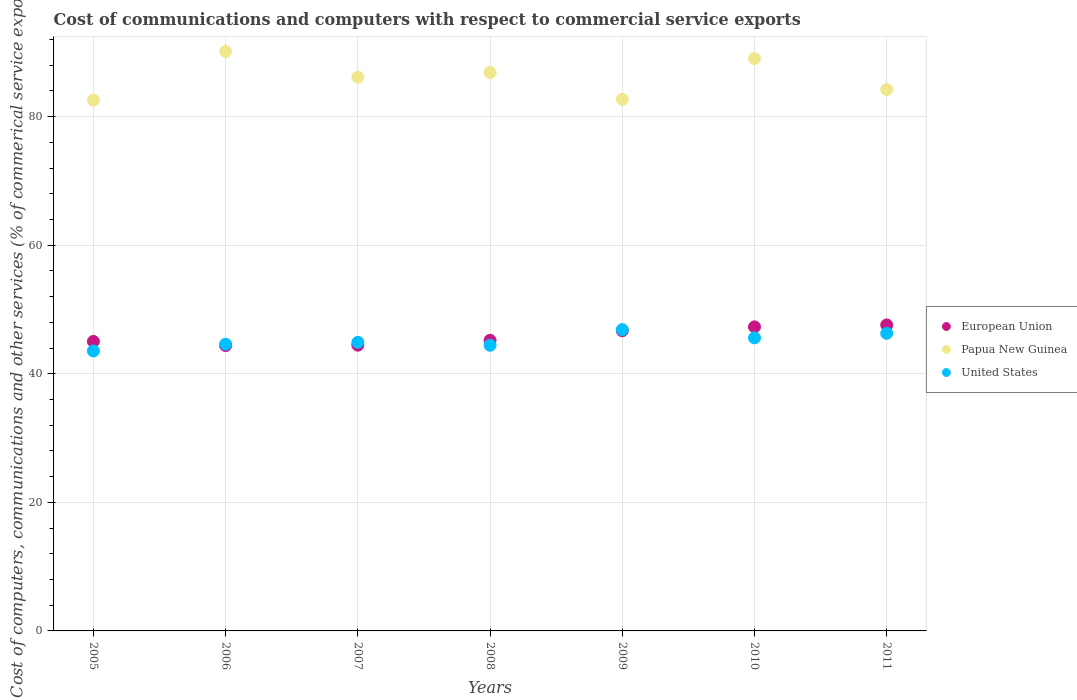Is the number of dotlines equal to the number of legend labels?
Make the answer very short. Yes. What is the cost of communications and computers in European Union in 2011?
Make the answer very short. 47.59. Across all years, what is the maximum cost of communications and computers in Papua New Guinea?
Provide a succinct answer. 90.12. Across all years, what is the minimum cost of communications and computers in United States?
Provide a short and direct response. 43.55. In which year was the cost of communications and computers in United States maximum?
Your answer should be compact. 2009. In which year was the cost of communications and computers in United States minimum?
Your response must be concise. 2005. What is the total cost of communications and computers in European Union in the graph?
Give a very brief answer. 320.63. What is the difference between the cost of communications and computers in Papua New Guinea in 2005 and that in 2007?
Ensure brevity in your answer.  -3.58. What is the difference between the cost of communications and computers in European Union in 2009 and the cost of communications and computers in United States in 2007?
Your response must be concise. 1.8. What is the average cost of communications and computers in United States per year?
Offer a very short reply. 45.17. In the year 2009, what is the difference between the cost of communications and computers in European Union and cost of communications and computers in United States?
Your answer should be compact. -0.17. In how many years, is the cost of communications and computers in United States greater than 28 %?
Keep it short and to the point. 7. What is the ratio of the cost of communications and computers in European Union in 2008 to that in 2010?
Make the answer very short. 0.96. What is the difference between the highest and the second highest cost of communications and computers in United States?
Your answer should be compact. 0.57. What is the difference between the highest and the lowest cost of communications and computers in United States?
Offer a terse response. 3.31. Is it the case that in every year, the sum of the cost of communications and computers in United States and cost of communications and computers in Papua New Guinea  is greater than the cost of communications and computers in European Union?
Provide a short and direct response. Yes. Is the cost of communications and computers in Papua New Guinea strictly greater than the cost of communications and computers in European Union over the years?
Ensure brevity in your answer.  Yes. What is the difference between two consecutive major ticks on the Y-axis?
Ensure brevity in your answer.  20. Are the values on the major ticks of Y-axis written in scientific E-notation?
Make the answer very short. No. Does the graph contain grids?
Provide a short and direct response. Yes. Where does the legend appear in the graph?
Your answer should be compact. Center right. How many legend labels are there?
Provide a short and direct response. 3. How are the legend labels stacked?
Your response must be concise. Vertical. What is the title of the graph?
Ensure brevity in your answer.  Cost of communications and computers with respect to commercial service exports. What is the label or title of the Y-axis?
Provide a succinct answer. Cost of computers, communications and other services (% of commerical service exports). What is the Cost of computers, communications and other services (% of commerical service exports) of European Union in 2005?
Offer a very short reply. 45.03. What is the Cost of computers, communications and other services (% of commerical service exports) in Papua New Guinea in 2005?
Offer a terse response. 82.56. What is the Cost of computers, communications and other services (% of commerical service exports) of United States in 2005?
Ensure brevity in your answer.  43.55. What is the Cost of computers, communications and other services (% of commerical service exports) in European Union in 2006?
Keep it short and to the point. 44.38. What is the Cost of computers, communications and other services (% of commerical service exports) of Papua New Guinea in 2006?
Give a very brief answer. 90.12. What is the Cost of computers, communications and other services (% of commerical service exports) of United States in 2006?
Your response must be concise. 44.6. What is the Cost of computers, communications and other services (% of commerical service exports) of European Union in 2007?
Your answer should be very brief. 44.44. What is the Cost of computers, communications and other services (% of commerical service exports) of Papua New Guinea in 2007?
Make the answer very short. 86.14. What is the Cost of computers, communications and other services (% of commerical service exports) of United States in 2007?
Keep it short and to the point. 44.89. What is the Cost of computers, communications and other services (% of commerical service exports) of European Union in 2008?
Give a very brief answer. 45.2. What is the Cost of computers, communications and other services (% of commerical service exports) in Papua New Guinea in 2008?
Make the answer very short. 86.87. What is the Cost of computers, communications and other services (% of commerical service exports) of United States in 2008?
Offer a terse response. 44.43. What is the Cost of computers, communications and other services (% of commerical service exports) of European Union in 2009?
Offer a very short reply. 46.69. What is the Cost of computers, communications and other services (% of commerical service exports) of Papua New Guinea in 2009?
Make the answer very short. 82.68. What is the Cost of computers, communications and other services (% of commerical service exports) of United States in 2009?
Provide a succinct answer. 46.86. What is the Cost of computers, communications and other services (% of commerical service exports) of European Union in 2010?
Your answer should be compact. 47.29. What is the Cost of computers, communications and other services (% of commerical service exports) of Papua New Guinea in 2010?
Your answer should be compact. 89.03. What is the Cost of computers, communications and other services (% of commerical service exports) in United States in 2010?
Give a very brief answer. 45.58. What is the Cost of computers, communications and other services (% of commerical service exports) of European Union in 2011?
Provide a short and direct response. 47.59. What is the Cost of computers, communications and other services (% of commerical service exports) of Papua New Guinea in 2011?
Make the answer very short. 84.21. What is the Cost of computers, communications and other services (% of commerical service exports) in United States in 2011?
Provide a succinct answer. 46.29. Across all years, what is the maximum Cost of computers, communications and other services (% of commerical service exports) in European Union?
Ensure brevity in your answer.  47.59. Across all years, what is the maximum Cost of computers, communications and other services (% of commerical service exports) in Papua New Guinea?
Offer a terse response. 90.12. Across all years, what is the maximum Cost of computers, communications and other services (% of commerical service exports) of United States?
Provide a succinct answer. 46.86. Across all years, what is the minimum Cost of computers, communications and other services (% of commerical service exports) in European Union?
Give a very brief answer. 44.38. Across all years, what is the minimum Cost of computers, communications and other services (% of commerical service exports) in Papua New Guinea?
Ensure brevity in your answer.  82.56. Across all years, what is the minimum Cost of computers, communications and other services (% of commerical service exports) in United States?
Ensure brevity in your answer.  43.55. What is the total Cost of computers, communications and other services (% of commerical service exports) in European Union in the graph?
Keep it short and to the point. 320.63. What is the total Cost of computers, communications and other services (% of commerical service exports) in Papua New Guinea in the graph?
Make the answer very short. 601.6. What is the total Cost of computers, communications and other services (% of commerical service exports) of United States in the graph?
Your answer should be compact. 316.21. What is the difference between the Cost of computers, communications and other services (% of commerical service exports) in European Union in 2005 and that in 2006?
Your answer should be compact. 0.65. What is the difference between the Cost of computers, communications and other services (% of commerical service exports) in Papua New Guinea in 2005 and that in 2006?
Your answer should be very brief. -7.56. What is the difference between the Cost of computers, communications and other services (% of commerical service exports) in United States in 2005 and that in 2006?
Make the answer very short. -1.05. What is the difference between the Cost of computers, communications and other services (% of commerical service exports) of European Union in 2005 and that in 2007?
Offer a very short reply. 0.59. What is the difference between the Cost of computers, communications and other services (% of commerical service exports) of Papua New Guinea in 2005 and that in 2007?
Your answer should be very brief. -3.58. What is the difference between the Cost of computers, communications and other services (% of commerical service exports) in United States in 2005 and that in 2007?
Offer a very short reply. -1.34. What is the difference between the Cost of computers, communications and other services (% of commerical service exports) in European Union in 2005 and that in 2008?
Make the answer very short. -0.17. What is the difference between the Cost of computers, communications and other services (% of commerical service exports) in Papua New Guinea in 2005 and that in 2008?
Ensure brevity in your answer.  -4.32. What is the difference between the Cost of computers, communications and other services (% of commerical service exports) of United States in 2005 and that in 2008?
Provide a short and direct response. -0.88. What is the difference between the Cost of computers, communications and other services (% of commerical service exports) of European Union in 2005 and that in 2009?
Your response must be concise. -1.66. What is the difference between the Cost of computers, communications and other services (% of commerical service exports) of Papua New Guinea in 2005 and that in 2009?
Offer a terse response. -0.12. What is the difference between the Cost of computers, communications and other services (% of commerical service exports) in United States in 2005 and that in 2009?
Ensure brevity in your answer.  -3.31. What is the difference between the Cost of computers, communications and other services (% of commerical service exports) of European Union in 2005 and that in 2010?
Keep it short and to the point. -2.26. What is the difference between the Cost of computers, communications and other services (% of commerical service exports) of Papua New Guinea in 2005 and that in 2010?
Offer a very short reply. -6.47. What is the difference between the Cost of computers, communications and other services (% of commerical service exports) of United States in 2005 and that in 2010?
Give a very brief answer. -2.03. What is the difference between the Cost of computers, communications and other services (% of commerical service exports) of European Union in 2005 and that in 2011?
Your response must be concise. -2.56. What is the difference between the Cost of computers, communications and other services (% of commerical service exports) of Papua New Guinea in 2005 and that in 2011?
Keep it short and to the point. -1.66. What is the difference between the Cost of computers, communications and other services (% of commerical service exports) of United States in 2005 and that in 2011?
Your answer should be very brief. -2.74. What is the difference between the Cost of computers, communications and other services (% of commerical service exports) of European Union in 2006 and that in 2007?
Keep it short and to the point. -0.06. What is the difference between the Cost of computers, communications and other services (% of commerical service exports) of Papua New Guinea in 2006 and that in 2007?
Provide a short and direct response. 3.98. What is the difference between the Cost of computers, communications and other services (% of commerical service exports) of United States in 2006 and that in 2007?
Provide a succinct answer. -0.3. What is the difference between the Cost of computers, communications and other services (% of commerical service exports) of European Union in 2006 and that in 2008?
Ensure brevity in your answer.  -0.82. What is the difference between the Cost of computers, communications and other services (% of commerical service exports) in Papua New Guinea in 2006 and that in 2008?
Make the answer very short. 3.25. What is the difference between the Cost of computers, communications and other services (% of commerical service exports) of United States in 2006 and that in 2008?
Offer a very short reply. 0.17. What is the difference between the Cost of computers, communications and other services (% of commerical service exports) of European Union in 2006 and that in 2009?
Offer a terse response. -2.31. What is the difference between the Cost of computers, communications and other services (% of commerical service exports) of Papua New Guinea in 2006 and that in 2009?
Your answer should be compact. 7.44. What is the difference between the Cost of computers, communications and other services (% of commerical service exports) of United States in 2006 and that in 2009?
Ensure brevity in your answer.  -2.27. What is the difference between the Cost of computers, communications and other services (% of commerical service exports) in European Union in 2006 and that in 2010?
Your answer should be very brief. -2.91. What is the difference between the Cost of computers, communications and other services (% of commerical service exports) of Papua New Guinea in 2006 and that in 2010?
Offer a very short reply. 1.09. What is the difference between the Cost of computers, communications and other services (% of commerical service exports) in United States in 2006 and that in 2010?
Your answer should be compact. -0.99. What is the difference between the Cost of computers, communications and other services (% of commerical service exports) of European Union in 2006 and that in 2011?
Provide a short and direct response. -3.21. What is the difference between the Cost of computers, communications and other services (% of commerical service exports) in Papua New Guinea in 2006 and that in 2011?
Your answer should be very brief. 5.9. What is the difference between the Cost of computers, communications and other services (% of commerical service exports) in United States in 2006 and that in 2011?
Provide a succinct answer. -1.7. What is the difference between the Cost of computers, communications and other services (% of commerical service exports) in European Union in 2007 and that in 2008?
Offer a very short reply. -0.76. What is the difference between the Cost of computers, communications and other services (% of commerical service exports) of Papua New Guinea in 2007 and that in 2008?
Offer a terse response. -0.73. What is the difference between the Cost of computers, communications and other services (% of commerical service exports) of United States in 2007 and that in 2008?
Your answer should be compact. 0.46. What is the difference between the Cost of computers, communications and other services (% of commerical service exports) in European Union in 2007 and that in 2009?
Keep it short and to the point. -2.25. What is the difference between the Cost of computers, communications and other services (% of commerical service exports) of Papua New Guinea in 2007 and that in 2009?
Provide a short and direct response. 3.46. What is the difference between the Cost of computers, communications and other services (% of commerical service exports) in United States in 2007 and that in 2009?
Ensure brevity in your answer.  -1.97. What is the difference between the Cost of computers, communications and other services (% of commerical service exports) in European Union in 2007 and that in 2010?
Provide a short and direct response. -2.85. What is the difference between the Cost of computers, communications and other services (% of commerical service exports) in Papua New Guinea in 2007 and that in 2010?
Give a very brief answer. -2.88. What is the difference between the Cost of computers, communications and other services (% of commerical service exports) of United States in 2007 and that in 2010?
Your answer should be very brief. -0.69. What is the difference between the Cost of computers, communications and other services (% of commerical service exports) in European Union in 2007 and that in 2011?
Provide a succinct answer. -3.15. What is the difference between the Cost of computers, communications and other services (% of commerical service exports) of Papua New Guinea in 2007 and that in 2011?
Provide a succinct answer. 1.93. What is the difference between the Cost of computers, communications and other services (% of commerical service exports) in United States in 2007 and that in 2011?
Make the answer very short. -1.4. What is the difference between the Cost of computers, communications and other services (% of commerical service exports) of European Union in 2008 and that in 2009?
Give a very brief answer. -1.49. What is the difference between the Cost of computers, communications and other services (% of commerical service exports) in Papua New Guinea in 2008 and that in 2009?
Your answer should be compact. 4.19. What is the difference between the Cost of computers, communications and other services (% of commerical service exports) in United States in 2008 and that in 2009?
Your answer should be compact. -2.43. What is the difference between the Cost of computers, communications and other services (% of commerical service exports) in European Union in 2008 and that in 2010?
Offer a very short reply. -2.09. What is the difference between the Cost of computers, communications and other services (% of commerical service exports) in Papua New Guinea in 2008 and that in 2010?
Ensure brevity in your answer.  -2.15. What is the difference between the Cost of computers, communications and other services (% of commerical service exports) in United States in 2008 and that in 2010?
Keep it short and to the point. -1.15. What is the difference between the Cost of computers, communications and other services (% of commerical service exports) in European Union in 2008 and that in 2011?
Give a very brief answer. -2.39. What is the difference between the Cost of computers, communications and other services (% of commerical service exports) in Papua New Guinea in 2008 and that in 2011?
Give a very brief answer. 2.66. What is the difference between the Cost of computers, communications and other services (% of commerical service exports) of United States in 2008 and that in 2011?
Provide a succinct answer. -1.86. What is the difference between the Cost of computers, communications and other services (% of commerical service exports) in European Union in 2009 and that in 2010?
Your response must be concise. -0.6. What is the difference between the Cost of computers, communications and other services (% of commerical service exports) in Papua New Guinea in 2009 and that in 2010?
Give a very brief answer. -6.35. What is the difference between the Cost of computers, communications and other services (% of commerical service exports) in United States in 2009 and that in 2010?
Your answer should be very brief. 1.28. What is the difference between the Cost of computers, communications and other services (% of commerical service exports) in European Union in 2009 and that in 2011?
Ensure brevity in your answer.  -0.9. What is the difference between the Cost of computers, communications and other services (% of commerical service exports) in Papua New Guinea in 2009 and that in 2011?
Provide a succinct answer. -1.53. What is the difference between the Cost of computers, communications and other services (% of commerical service exports) of United States in 2009 and that in 2011?
Your response must be concise. 0.57. What is the difference between the Cost of computers, communications and other services (% of commerical service exports) of European Union in 2010 and that in 2011?
Your answer should be compact. -0.3. What is the difference between the Cost of computers, communications and other services (% of commerical service exports) of Papua New Guinea in 2010 and that in 2011?
Keep it short and to the point. 4.81. What is the difference between the Cost of computers, communications and other services (% of commerical service exports) of United States in 2010 and that in 2011?
Your answer should be very brief. -0.71. What is the difference between the Cost of computers, communications and other services (% of commerical service exports) in European Union in 2005 and the Cost of computers, communications and other services (% of commerical service exports) in Papua New Guinea in 2006?
Offer a terse response. -45.09. What is the difference between the Cost of computers, communications and other services (% of commerical service exports) of European Union in 2005 and the Cost of computers, communications and other services (% of commerical service exports) of United States in 2006?
Keep it short and to the point. 0.44. What is the difference between the Cost of computers, communications and other services (% of commerical service exports) of Papua New Guinea in 2005 and the Cost of computers, communications and other services (% of commerical service exports) of United States in 2006?
Ensure brevity in your answer.  37.96. What is the difference between the Cost of computers, communications and other services (% of commerical service exports) in European Union in 2005 and the Cost of computers, communications and other services (% of commerical service exports) in Papua New Guinea in 2007?
Your response must be concise. -41.11. What is the difference between the Cost of computers, communications and other services (% of commerical service exports) in European Union in 2005 and the Cost of computers, communications and other services (% of commerical service exports) in United States in 2007?
Your answer should be compact. 0.14. What is the difference between the Cost of computers, communications and other services (% of commerical service exports) of Papua New Guinea in 2005 and the Cost of computers, communications and other services (% of commerical service exports) of United States in 2007?
Provide a succinct answer. 37.66. What is the difference between the Cost of computers, communications and other services (% of commerical service exports) of European Union in 2005 and the Cost of computers, communications and other services (% of commerical service exports) of Papua New Guinea in 2008?
Give a very brief answer. -41.84. What is the difference between the Cost of computers, communications and other services (% of commerical service exports) of European Union in 2005 and the Cost of computers, communications and other services (% of commerical service exports) of United States in 2008?
Offer a very short reply. 0.6. What is the difference between the Cost of computers, communications and other services (% of commerical service exports) of Papua New Guinea in 2005 and the Cost of computers, communications and other services (% of commerical service exports) of United States in 2008?
Your response must be concise. 38.13. What is the difference between the Cost of computers, communications and other services (% of commerical service exports) of European Union in 2005 and the Cost of computers, communications and other services (% of commerical service exports) of Papua New Guinea in 2009?
Your response must be concise. -37.65. What is the difference between the Cost of computers, communications and other services (% of commerical service exports) in European Union in 2005 and the Cost of computers, communications and other services (% of commerical service exports) in United States in 2009?
Keep it short and to the point. -1.83. What is the difference between the Cost of computers, communications and other services (% of commerical service exports) in Papua New Guinea in 2005 and the Cost of computers, communications and other services (% of commerical service exports) in United States in 2009?
Provide a short and direct response. 35.69. What is the difference between the Cost of computers, communications and other services (% of commerical service exports) in European Union in 2005 and the Cost of computers, communications and other services (% of commerical service exports) in Papua New Guinea in 2010?
Your answer should be very brief. -43.99. What is the difference between the Cost of computers, communications and other services (% of commerical service exports) of European Union in 2005 and the Cost of computers, communications and other services (% of commerical service exports) of United States in 2010?
Offer a very short reply. -0.55. What is the difference between the Cost of computers, communications and other services (% of commerical service exports) in Papua New Guinea in 2005 and the Cost of computers, communications and other services (% of commerical service exports) in United States in 2010?
Offer a terse response. 36.97. What is the difference between the Cost of computers, communications and other services (% of commerical service exports) in European Union in 2005 and the Cost of computers, communications and other services (% of commerical service exports) in Papua New Guinea in 2011?
Offer a very short reply. -39.18. What is the difference between the Cost of computers, communications and other services (% of commerical service exports) in European Union in 2005 and the Cost of computers, communications and other services (% of commerical service exports) in United States in 2011?
Your answer should be compact. -1.26. What is the difference between the Cost of computers, communications and other services (% of commerical service exports) of Papua New Guinea in 2005 and the Cost of computers, communications and other services (% of commerical service exports) of United States in 2011?
Provide a succinct answer. 36.26. What is the difference between the Cost of computers, communications and other services (% of commerical service exports) in European Union in 2006 and the Cost of computers, communications and other services (% of commerical service exports) in Papua New Guinea in 2007?
Give a very brief answer. -41.76. What is the difference between the Cost of computers, communications and other services (% of commerical service exports) of European Union in 2006 and the Cost of computers, communications and other services (% of commerical service exports) of United States in 2007?
Give a very brief answer. -0.51. What is the difference between the Cost of computers, communications and other services (% of commerical service exports) of Papua New Guinea in 2006 and the Cost of computers, communications and other services (% of commerical service exports) of United States in 2007?
Offer a very short reply. 45.22. What is the difference between the Cost of computers, communications and other services (% of commerical service exports) in European Union in 2006 and the Cost of computers, communications and other services (% of commerical service exports) in Papua New Guinea in 2008?
Give a very brief answer. -42.49. What is the difference between the Cost of computers, communications and other services (% of commerical service exports) of European Union in 2006 and the Cost of computers, communications and other services (% of commerical service exports) of United States in 2008?
Offer a very short reply. -0.05. What is the difference between the Cost of computers, communications and other services (% of commerical service exports) of Papua New Guinea in 2006 and the Cost of computers, communications and other services (% of commerical service exports) of United States in 2008?
Provide a succinct answer. 45.69. What is the difference between the Cost of computers, communications and other services (% of commerical service exports) of European Union in 2006 and the Cost of computers, communications and other services (% of commerical service exports) of Papua New Guinea in 2009?
Keep it short and to the point. -38.3. What is the difference between the Cost of computers, communications and other services (% of commerical service exports) in European Union in 2006 and the Cost of computers, communications and other services (% of commerical service exports) in United States in 2009?
Give a very brief answer. -2.48. What is the difference between the Cost of computers, communications and other services (% of commerical service exports) of Papua New Guinea in 2006 and the Cost of computers, communications and other services (% of commerical service exports) of United States in 2009?
Provide a succinct answer. 43.25. What is the difference between the Cost of computers, communications and other services (% of commerical service exports) of European Union in 2006 and the Cost of computers, communications and other services (% of commerical service exports) of Papua New Guinea in 2010?
Offer a terse response. -44.65. What is the difference between the Cost of computers, communications and other services (% of commerical service exports) in European Union in 2006 and the Cost of computers, communications and other services (% of commerical service exports) in United States in 2010?
Your answer should be compact. -1.2. What is the difference between the Cost of computers, communications and other services (% of commerical service exports) in Papua New Guinea in 2006 and the Cost of computers, communications and other services (% of commerical service exports) in United States in 2010?
Provide a short and direct response. 44.53. What is the difference between the Cost of computers, communications and other services (% of commerical service exports) in European Union in 2006 and the Cost of computers, communications and other services (% of commerical service exports) in Papua New Guinea in 2011?
Keep it short and to the point. -39.84. What is the difference between the Cost of computers, communications and other services (% of commerical service exports) of European Union in 2006 and the Cost of computers, communications and other services (% of commerical service exports) of United States in 2011?
Offer a very short reply. -1.91. What is the difference between the Cost of computers, communications and other services (% of commerical service exports) of Papua New Guinea in 2006 and the Cost of computers, communications and other services (% of commerical service exports) of United States in 2011?
Give a very brief answer. 43.82. What is the difference between the Cost of computers, communications and other services (% of commerical service exports) in European Union in 2007 and the Cost of computers, communications and other services (% of commerical service exports) in Papua New Guinea in 2008?
Offer a terse response. -42.43. What is the difference between the Cost of computers, communications and other services (% of commerical service exports) of European Union in 2007 and the Cost of computers, communications and other services (% of commerical service exports) of United States in 2008?
Your answer should be very brief. 0.01. What is the difference between the Cost of computers, communications and other services (% of commerical service exports) in Papua New Guinea in 2007 and the Cost of computers, communications and other services (% of commerical service exports) in United States in 2008?
Offer a terse response. 41.71. What is the difference between the Cost of computers, communications and other services (% of commerical service exports) in European Union in 2007 and the Cost of computers, communications and other services (% of commerical service exports) in Papua New Guinea in 2009?
Offer a very short reply. -38.24. What is the difference between the Cost of computers, communications and other services (% of commerical service exports) of European Union in 2007 and the Cost of computers, communications and other services (% of commerical service exports) of United States in 2009?
Offer a very short reply. -2.42. What is the difference between the Cost of computers, communications and other services (% of commerical service exports) in Papua New Guinea in 2007 and the Cost of computers, communications and other services (% of commerical service exports) in United States in 2009?
Make the answer very short. 39.28. What is the difference between the Cost of computers, communications and other services (% of commerical service exports) in European Union in 2007 and the Cost of computers, communications and other services (% of commerical service exports) in Papua New Guinea in 2010?
Make the answer very short. -44.58. What is the difference between the Cost of computers, communications and other services (% of commerical service exports) in European Union in 2007 and the Cost of computers, communications and other services (% of commerical service exports) in United States in 2010?
Offer a terse response. -1.14. What is the difference between the Cost of computers, communications and other services (% of commerical service exports) of Papua New Guinea in 2007 and the Cost of computers, communications and other services (% of commerical service exports) of United States in 2010?
Your response must be concise. 40.56. What is the difference between the Cost of computers, communications and other services (% of commerical service exports) in European Union in 2007 and the Cost of computers, communications and other services (% of commerical service exports) in Papua New Guinea in 2011?
Offer a terse response. -39.77. What is the difference between the Cost of computers, communications and other services (% of commerical service exports) in European Union in 2007 and the Cost of computers, communications and other services (% of commerical service exports) in United States in 2011?
Keep it short and to the point. -1.85. What is the difference between the Cost of computers, communications and other services (% of commerical service exports) in Papua New Guinea in 2007 and the Cost of computers, communications and other services (% of commerical service exports) in United States in 2011?
Make the answer very short. 39.85. What is the difference between the Cost of computers, communications and other services (% of commerical service exports) of European Union in 2008 and the Cost of computers, communications and other services (% of commerical service exports) of Papua New Guinea in 2009?
Your answer should be compact. -37.48. What is the difference between the Cost of computers, communications and other services (% of commerical service exports) of European Union in 2008 and the Cost of computers, communications and other services (% of commerical service exports) of United States in 2009?
Give a very brief answer. -1.66. What is the difference between the Cost of computers, communications and other services (% of commerical service exports) in Papua New Guinea in 2008 and the Cost of computers, communications and other services (% of commerical service exports) in United States in 2009?
Offer a very short reply. 40.01. What is the difference between the Cost of computers, communications and other services (% of commerical service exports) in European Union in 2008 and the Cost of computers, communications and other services (% of commerical service exports) in Papua New Guinea in 2010?
Ensure brevity in your answer.  -43.83. What is the difference between the Cost of computers, communications and other services (% of commerical service exports) in European Union in 2008 and the Cost of computers, communications and other services (% of commerical service exports) in United States in 2010?
Offer a terse response. -0.38. What is the difference between the Cost of computers, communications and other services (% of commerical service exports) in Papua New Guinea in 2008 and the Cost of computers, communications and other services (% of commerical service exports) in United States in 2010?
Give a very brief answer. 41.29. What is the difference between the Cost of computers, communications and other services (% of commerical service exports) of European Union in 2008 and the Cost of computers, communications and other services (% of commerical service exports) of Papua New Guinea in 2011?
Offer a terse response. -39.01. What is the difference between the Cost of computers, communications and other services (% of commerical service exports) of European Union in 2008 and the Cost of computers, communications and other services (% of commerical service exports) of United States in 2011?
Provide a succinct answer. -1.09. What is the difference between the Cost of computers, communications and other services (% of commerical service exports) of Papua New Guinea in 2008 and the Cost of computers, communications and other services (% of commerical service exports) of United States in 2011?
Your answer should be compact. 40.58. What is the difference between the Cost of computers, communications and other services (% of commerical service exports) in European Union in 2009 and the Cost of computers, communications and other services (% of commerical service exports) in Papua New Guinea in 2010?
Provide a short and direct response. -42.33. What is the difference between the Cost of computers, communications and other services (% of commerical service exports) in European Union in 2009 and the Cost of computers, communications and other services (% of commerical service exports) in United States in 2010?
Make the answer very short. 1.11. What is the difference between the Cost of computers, communications and other services (% of commerical service exports) in Papua New Guinea in 2009 and the Cost of computers, communications and other services (% of commerical service exports) in United States in 2010?
Offer a terse response. 37.1. What is the difference between the Cost of computers, communications and other services (% of commerical service exports) in European Union in 2009 and the Cost of computers, communications and other services (% of commerical service exports) in Papua New Guinea in 2011?
Provide a short and direct response. -37.52. What is the difference between the Cost of computers, communications and other services (% of commerical service exports) in European Union in 2009 and the Cost of computers, communications and other services (% of commerical service exports) in United States in 2011?
Keep it short and to the point. 0.4. What is the difference between the Cost of computers, communications and other services (% of commerical service exports) in Papua New Guinea in 2009 and the Cost of computers, communications and other services (% of commerical service exports) in United States in 2011?
Offer a terse response. 36.39. What is the difference between the Cost of computers, communications and other services (% of commerical service exports) of European Union in 2010 and the Cost of computers, communications and other services (% of commerical service exports) of Papua New Guinea in 2011?
Make the answer very short. -36.92. What is the difference between the Cost of computers, communications and other services (% of commerical service exports) in Papua New Guinea in 2010 and the Cost of computers, communications and other services (% of commerical service exports) in United States in 2011?
Your response must be concise. 42.73. What is the average Cost of computers, communications and other services (% of commerical service exports) of European Union per year?
Offer a very short reply. 45.8. What is the average Cost of computers, communications and other services (% of commerical service exports) in Papua New Guinea per year?
Your answer should be very brief. 85.94. What is the average Cost of computers, communications and other services (% of commerical service exports) in United States per year?
Ensure brevity in your answer.  45.17. In the year 2005, what is the difference between the Cost of computers, communications and other services (% of commerical service exports) of European Union and Cost of computers, communications and other services (% of commerical service exports) of Papua New Guinea?
Make the answer very short. -37.52. In the year 2005, what is the difference between the Cost of computers, communications and other services (% of commerical service exports) in European Union and Cost of computers, communications and other services (% of commerical service exports) in United States?
Your answer should be compact. 1.48. In the year 2005, what is the difference between the Cost of computers, communications and other services (% of commerical service exports) in Papua New Guinea and Cost of computers, communications and other services (% of commerical service exports) in United States?
Give a very brief answer. 39. In the year 2006, what is the difference between the Cost of computers, communications and other services (% of commerical service exports) in European Union and Cost of computers, communications and other services (% of commerical service exports) in Papua New Guinea?
Your answer should be compact. -45.74. In the year 2006, what is the difference between the Cost of computers, communications and other services (% of commerical service exports) of European Union and Cost of computers, communications and other services (% of commerical service exports) of United States?
Ensure brevity in your answer.  -0.22. In the year 2006, what is the difference between the Cost of computers, communications and other services (% of commerical service exports) in Papua New Guinea and Cost of computers, communications and other services (% of commerical service exports) in United States?
Give a very brief answer. 45.52. In the year 2007, what is the difference between the Cost of computers, communications and other services (% of commerical service exports) of European Union and Cost of computers, communications and other services (% of commerical service exports) of Papua New Guinea?
Your answer should be very brief. -41.7. In the year 2007, what is the difference between the Cost of computers, communications and other services (% of commerical service exports) in European Union and Cost of computers, communications and other services (% of commerical service exports) in United States?
Keep it short and to the point. -0.45. In the year 2007, what is the difference between the Cost of computers, communications and other services (% of commerical service exports) of Papua New Guinea and Cost of computers, communications and other services (% of commerical service exports) of United States?
Give a very brief answer. 41.25. In the year 2008, what is the difference between the Cost of computers, communications and other services (% of commerical service exports) in European Union and Cost of computers, communications and other services (% of commerical service exports) in Papua New Guinea?
Keep it short and to the point. -41.67. In the year 2008, what is the difference between the Cost of computers, communications and other services (% of commerical service exports) of European Union and Cost of computers, communications and other services (% of commerical service exports) of United States?
Your answer should be very brief. 0.77. In the year 2008, what is the difference between the Cost of computers, communications and other services (% of commerical service exports) in Papua New Guinea and Cost of computers, communications and other services (% of commerical service exports) in United States?
Offer a terse response. 42.44. In the year 2009, what is the difference between the Cost of computers, communications and other services (% of commerical service exports) of European Union and Cost of computers, communications and other services (% of commerical service exports) of Papua New Guinea?
Offer a very short reply. -35.99. In the year 2009, what is the difference between the Cost of computers, communications and other services (% of commerical service exports) in European Union and Cost of computers, communications and other services (% of commerical service exports) in United States?
Provide a succinct answer. -0.17. In the year 2009, what is the difference between the Cost of computers, communications and other services (% of commerical service exports) in Papua New Guinea and Cost of computers, communications and other services (% of commerical service exports) in United States?
Provide a short and direct response. 35.82. In the year 2010, what is the difference between the Cost of computers, communications and other services (% of commerical service exports) of European Union and Cost of computers, communications and other services (% of commerical service exports) of Papua New Guinea?
Provide a succinct answer. -41.73. In the year 2010, what is the difference between the Cost of computers, communications and other services (% of commerical service exports) of European Union and Cost of computers, communications and other services (% of commerical service exports) of United States?
Your answer should be very brief. 1.71. In the year 2010, what is the difference between the Cost of computers, communications and other services (% of commerical service exports) of Papua New Guinea and Cost of computers, communications and other services (% of commerical service exports) of United States?
Ensure brevity in your answer.  43.44. In the year 2011, what is the difference between the Cost of computers, communications and other services (% of commerical service exports) of European Union and Cost of computers, communications and other services (% of commerical service exports) of Papua New Guinea?
Your answer should be compact. -36.62. In the year 2011, what is the difference between the Cost of computers, communications and other services (% of commerical service exports) in European Union and Cost of computers, communications and other services (% of commerical service exports) in United States?
Offer a terse response. 1.3. In the year 2011, what is the difference between the Cost of computers, communications and other services (% of commerical service exports) of Papua New Guinea and Cost of computers, communications and other services (% of commerical service exports) of United States?
Offer a terse response. 37.92. What is the ratio of the Cost of computers, communications and other services (% of commerical service exports) in European Union in 2005 to that in 2006?
Your answer should be compact. 1.01. What is the ratio of the Cost of computers, communications and other services (% of commerical service exports) of Papua New Guinea in 2005 to that in 2006?
Provide a short and direct response. 0.92. What is the ratio of the Cost of computers, communications and other services (% of commerical service exports) of United States in 2005 to that in 2006?
Provide a succinct answer. 0.98. What is the ratio of the Cost of computers, communications and other services (% of commerical service exports) of European Union in 2005 to that in 2007?
Your answer should be compact. 1.01. What is the ratio of the Cost of computers, communications and other services (% of commerical service exports) in Papua New Guinea in 2005 to that in 2007?
Keep it short and to the point. 0.96. What is the ratio of the Cost of computers, communications and other services (% of commerical service exports) of United States in 2005 to that in 2007?
Offer a very short reply. 0.97. What is the ratio of the Cost of computers, communications and other services (% of commerical service exports) of European Union in 2005 to that in 2008?
Keep it short and to the point. 1. What is the ratio of the Cost of computers, communications and other services (% of commerical service exports) in Papua New Guinea in 2005 to that in 2008?
Offer a very short reply. 0.95. What is the ratio of the Cost of computers, communications and other services (% of commerical service exports) of United States in 2005 to that in 2008?
Offer a terse response. 0.98. What is the ratio of the Cost of computers, communications and other services (% of commerical service exports) in European Union in 2005 to that in 2009?
Your answer should be very brief. 0.96. What is the ratio of the Cost of computers, communications and other services (% of commerical service exports) in Papua New Guinea in 2005 to that in 2009?
Offer a very short reply. 1. What is the ratio of the Cost of computers, communications and other services (% of commerical service exports) in United States in 2005 to that in 2009?
Ensure brevity in your answer.  0.93. What is the ratio of the Cost of computers, communications and other services (% of commerical service exports) of European Union in 2005 to that in 2010?
Your answer should be very brief. 0.95. What is the ratio of the Cost of computers, communications and other services (% of commerical service exports) of Papua New Guinea in 2005 to that in 2010?
Make the answer very short. 0.93. What is the ratio of the Cost of computers, communications and other services (% of commerical service exports) in United States in 2005 to that in 2010?
Your answer should be very brief. 0.96. What is the ratio of the Cost of computers, communications and other services (% of commerical service exports) of European Union in 2005 to that in 2011?
Provide a short and direct response. 0.95. What is the ratio of the Cost of computers, communications and other services (% of commerical service exports) of Papua New Guinea in 2005 to that in 2011?
Offer a very short reply. 0.98. What is the ratio of the Cost of computers, communications and other services (% of commerical service exports) of United States in 2005 to that in 2011?
Provide a short and direct response. 0.94. What is the ratio of the Cost of computers, communications and other services (% of commerical service exports) of European Union in 2006 to that in 2007?
Keep it short and to the point. 1. What is the ratio of the Cost of computers, communications and other services (% of commerical service exports) in Papua New Guinea in 2006 to that in 2007?
Make the answer very short. 1.05. What is the ratio of the Cost of computers, communications and other services (% of commerical service exports) of European Union in 2006 to that in 2008?
Keep it short and to the point. 0.98. What is the ratio of the Cost of computers, communications and other services (% of commerical service exports) of Papua New Guinea in 2006 to that in 2008?
Ensure brevity in your answer.  1.04. What is the ratio of the Cost of computers, communications and other services (% of commerical service exports) in European Union in 2006 to that in 2009?
Provide a short and direct response. 0.95. What is the ratio of the Cost of computers, communications and other services (% of commerical service exports) of Papua New Guinea in 2006 to that in 2009?
Offer a terse response. 1.09. What is the ratio of the Cost of computers, communications and other services (% of commerical service exports) in United States in 2006 to that in 2009?
Your answer should be compact. 0.95. What is the ratio of the Cost of computers, communications and other services (% of commerical service exports) of European Union in 2006 to that in 2010?
Provide a short and direct response. 0.94. What is the ratio of the Cost of computers, communications and other services (% of commerical service exports) in Papua New Guinea in 2006 to that in 2010?
Provide a succinct answer. 1.01. What is the ratio of the Cost of computers, communications and other services (% of commerical service exports) of United States in 2006 to that in 2010?
Ensure brevity in your answer.  0.98. What is the ratio of the Cost of computers, communications and other services (% of commerical service exports) in European Union in 2006 to that in 2011?
Offer a very short reply. 0.93. What is the ratio of the Cost of computers, communications and other services (% of commerical service exports) in Papua New Guinea in 2006 to that in 2011?
Provide a succinct answer. 1.07. What is the ratio of the Cost of computers, communications and other services (% of commerical service exports) of United States in 2006 to that in 2011?
Your response must be concise. 0.96. What is the ratio of the Cost of computers, communications and other services (% of commerical service exports) of European Union in 2007 to that in 2008?
Offer a terse response. 0.98. What is the ratio of the Cost of computers, communications and other services (% of commerical service exports) in United States in 2007 to that in 2008?
Keep it short and to the point. 1.01. What is the ratio of the Cost of computers, communications and other services (% of commerical service exports) in European Union in 2007 to that in 2009?
Keep it short and to the point. 0.95. What is the ratio of the Cost of computers, communications and other services (% of commerical service exports) in Papua New Guinea in 2007 to that in 2009?
Provide a succinct answer. 1.04. What is the ratio of the Cost of computers, communications and other services (% of commerical service exports) in United States in 2007 to that in 2009?
Give a very brief answer. 0.96. What is the ratio of the Cost of computers, communications and other services (% of commerical service exports) of European Union in 2007 to that in 2010?
Ensure brevity in your answer.  0.94. What is the ratio of the Cost of computers, communications and other services (% of commerical service exports) of Papua New Guinea in 2007 to that in 2010?
Offer a very short reply. 0.97. What is the ratio of the Cost of computers, communications and other services (% of commerical service exports) in United States in 2007 to that in 2010?
Ensure brevity in your answer.  0.98. What is the ratio of the Cost of computers, communications and other services (% of commerical service exports) in European Union in 2007 to that in 2011?
Ensure brevity in your answer.  0.93. What is the ratio of the Cost of computers, communications and other services (% of commerical service exports) in Papua New Guinea in 2007 to that in 2011?
Offer a terse response. 1.02. What is the ratio of the Cost of computers, communications and other services (% of commerical service exports) in United States in 2007 to that in 2011?
Your answer should be very brief. 0.97. What is the ratio of the Cost of computers, communications and other services (% of commerical service exports) of European Union in 2008 to that in 2009?
Your answer should be compact. 0.97. What is the ratio of the Cost of computers, communications and other services (% of commerical service exports) of Papua New Guinea in 2008 to that in 2009?
Give a very brief answer. 1.05. What is the ratio of the Cost of computers, communications and other services (% of commerical service exports) in United States in 2008 to that in 2009?
Offer a very short reply. 0.95. What is the ratio of the Cost of computers, communications and other services (% of commerical service exports) of European Union in 2008 to that in 2010?
Your answer should be very brief. 0.96. What is the ratio of the Cost of computers, communications and other services (% of commerical service exports) in Papua New Guinea in 2008 to that in 2010?
Your response must be concise. 0.98. What is the ratio of the Cost of computers, communications and other services (% of commerical service exports) of United States in 2008 to that in 2010?
Make the answer very short. 0.97. What is the ratio of the Cost of computers, communications and other services (% of commerical service exports) in European Union in 2008 to that in 2011?
Make the answer very short. 0.95. What is the ratio of the Cost of computers, communications and other services (% of commerical service exports) of Papua New Guinea in 2008 to that in 2011?
Your answer should be very brief. 1.03. What is the ratio of the Cost of computers, communications and other services (% of commerical service exports) of United States in 2008 to that in 2011?
Give a very brief answer. 0.96. What is the ratio of the Cost of computers, communications and other services (% of commerical service exports) of European Union in 2009 to that in 2010?
Your answer should be very brief. 0.99. What is the ratio of the Cost of computers, communications and other services (% of commerical service exports) in Papua New Guinea in 2009 to that in 2010?
Your answer should be compact. 0.93. What is the ratio of the Cost of computers, communications and other services (% of commerical service exports) of United States in 2009 to that in 2010?
Your answer should be compact. 1.03. What is the ratio of the Cost of computers, communications and other services (% of commerical service exports) of European Union in 2009 to that in 2011?
Ensure brevity in your answer.  0.98. What is the ratio of the Cost of computers, communications and other services (% of commerical service exports) in Papua New Guinea in 2009 to that in 2011?
Offer a very short reply. 0.98. What is the ratio of the Cost of computers, communications and other services (% of commerical service exports) in United States in 2009 to that in 2011?
Make the answer very short. 1.01. What is the ratio of the Cost of computers, communications and other services (% of commerical service exports) of Papua New Guinea in 2010 to that in 2011?
Give a very brief answer. 1.06. What is the ratio of the Cost of computers, communications and other services (% of commerical service exports) in United States in 2010 to that in 2011?
Your answer should be very brief. 0.98. What is the difference between the highest and the second highest Cost of computers, communications and other services (% of commerical service exports) in European Union?
Offer a terse response. 0.3. What is the difference between the highest and the second highest Cost of computers, communications and other services (% of commerical service exports) in Papua New Guinea?
Offer a very short reply. 1.09. What is the difference between the highest and the second highest Cost of computers, communications and other services (% of commerical service exports) in United States?
Ensure brevity in your answer.  0.57. What is the difference between the highest and the lowest Cost of computers, communications and other services (% of commerical service exports) of European Union?
Keep it short and to the point. 3.21. What is the difference between the highest and the lowest Cost of computers, communications and other services (% of commerical service exports) in Papua New Guinea?
Give a very brief answer. 7.56. What is the difference between the highest and the lowest Cost of computers, communications and other services (% of commerical service exports) in United States?
Give a very brief answer. 3.31. 